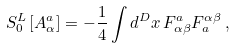<formula> <loc_0><loc_0><loc_500><loc_500>S _ { 0 } ^ { L } \left [ A _ { \alpha } ^ { a } \right ] = - \frac { 1 } { 4 } \int d ^ { D } x \, F _ { \alpha \beta } ^ { a } F _ { a } ^ { \alpha \beta } \, ,</formula> 